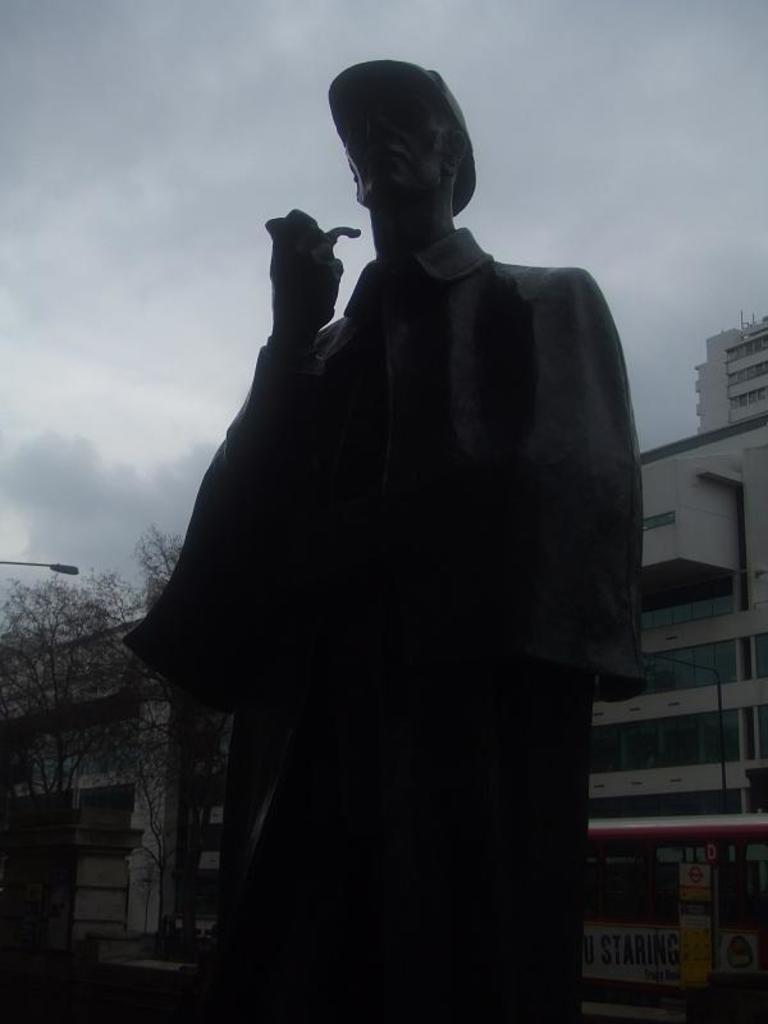Please provide a concise description of this image. This picture is clicked outside. In the foreground there is a sculpture of a person. In the background there is a sky, buildings, trees and a street light. 